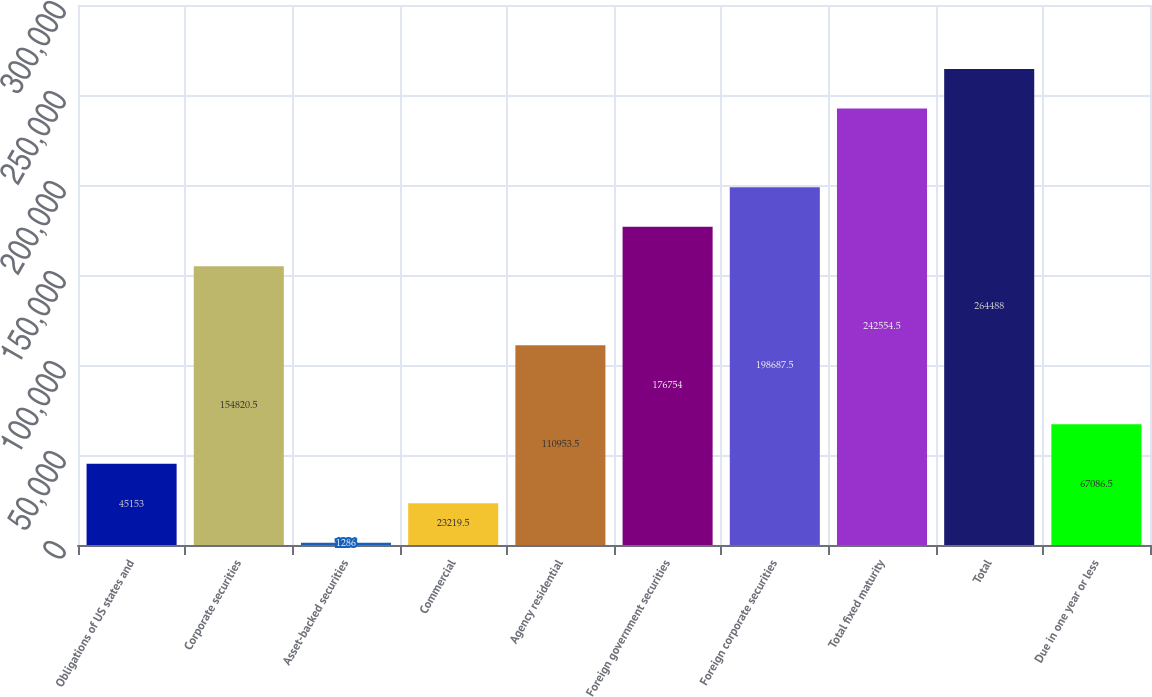Convert chart. <chart><loc_0><loc_0><loc_500><loc_500><bar_chart><fcel>Obligations of US states and<fcel>Corporate securities<fcel>Asset-backed securities<fcel>Commercial<fcel>Agency residential<fcel>Foreign government securities<fcel>Foreign corporate securities<fcel>Total fixed maturity<fcel>Total<fcel>Due in one year or less<nl><fcel>45153<fcel>154820<fcel>1286<fcel>23219.5<fcel>110954<fcel>176754<fcel>198688<fcel>242554<fcel>264488<fcel>67086.5<nl></chart> 